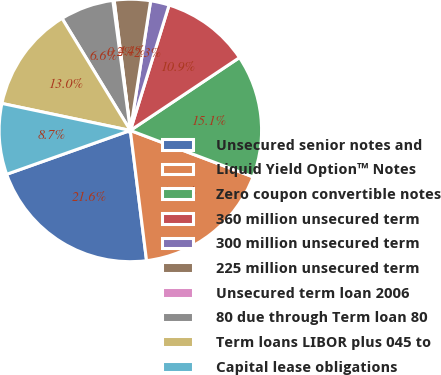Convert chart to OTSL. <chart><loc_0><loc_0><loc_500><loc_500><pie_chart><fcel>Unsecured senior notes and<fcel>Liquid Yield Option™ Notes<fcel>Zero coupon convertible notes<fcel>360 million unsecured term<fcel>300 million unsecured term<fcel>225 million unsecured term<fcel>Unsecured term loan 2006<fcel>80 due through Term loan 80<fcel>Term loans LIBOR plus 045 to<fcel>Capital lease obligations<nl><fcel>21.55%<fcel>17.27%<fcel>15.13%<fcel>10.86%<fcel>2.3%<fcel>4.44%<fcel>0.16%<fcel>6.58%<fcel>12.99%<fcel>8.72%<nl></chart> 